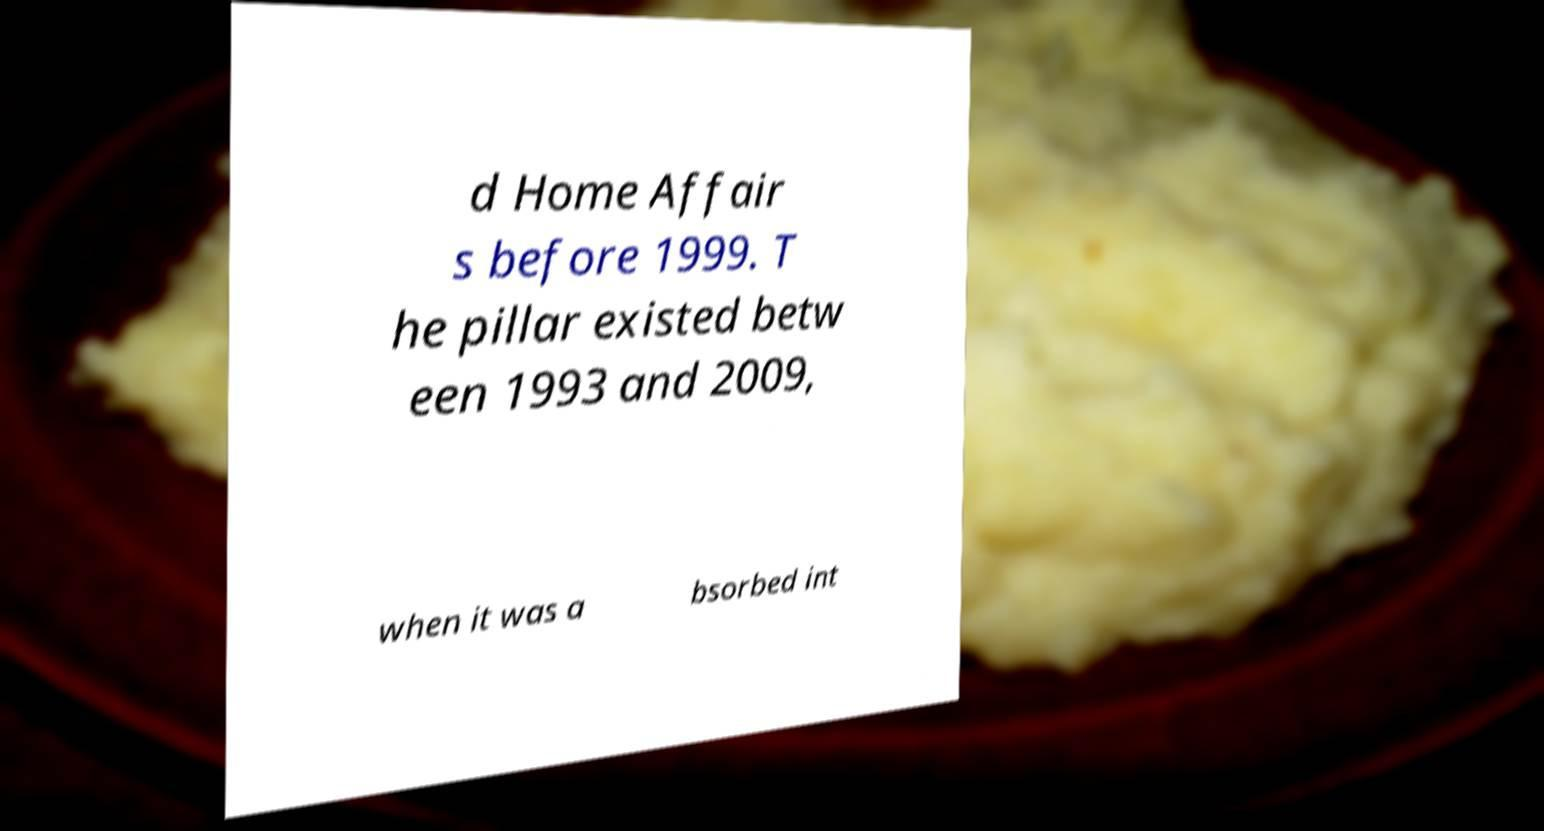Can you read and provide the text displayed in the image?This photo seems to have some interesting text. Can you extract and type it out for me? d Home Affair s before 1999. T he pillar existed betw een 1993 and 2009, when it was a bsorbed int 